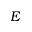<formula> <loc_0><loc_0><loc_500><loc_500>E</formula> 